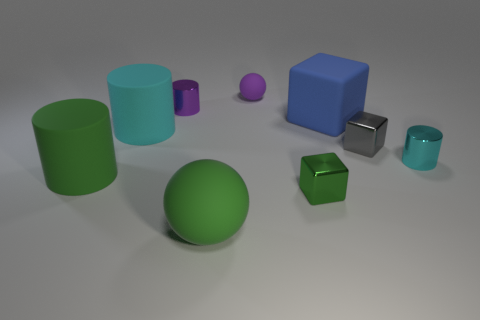Does the purple metal object have the same shape as the tiny green metallic thing?
Offer a terse response. No. What shape is the purple thing that is made of the same material as the large cyan cylinder?
Provide a succinct answer. Sphere. There is a matte cylinder that is behind the cylinder that is on the right side of the large ball; what is its size?
Ensure brevity in your answer.  Large. What is the color of the cylinder that is on the right side of the blue object?
Make the answer very short. Cyan. Is there a blue object of the same shape as the small gray metallic thing?
Give a very brief answer. Yes. Are there fewer green balls that are to the right of the big blue cube than big green cylinders that are in front of the small cyan metallic cylinder?
Your response must be concise. Yes. What color is the large cube?
Keep it short and to the point. Blue. Is there a tiny cyan cylinder in front of the small shiny block on the left side of the small gray metallic cube?
Provide a short and direct response. No. How many purple metal things are the same size as the purple sphere?
Provide a short and direct response. 1. What number of shiny cubes are in front of the rubber cylinder that is in front of the shiny cylinder that is to the right of the green metal thing?
Offer a terse response. 1. 